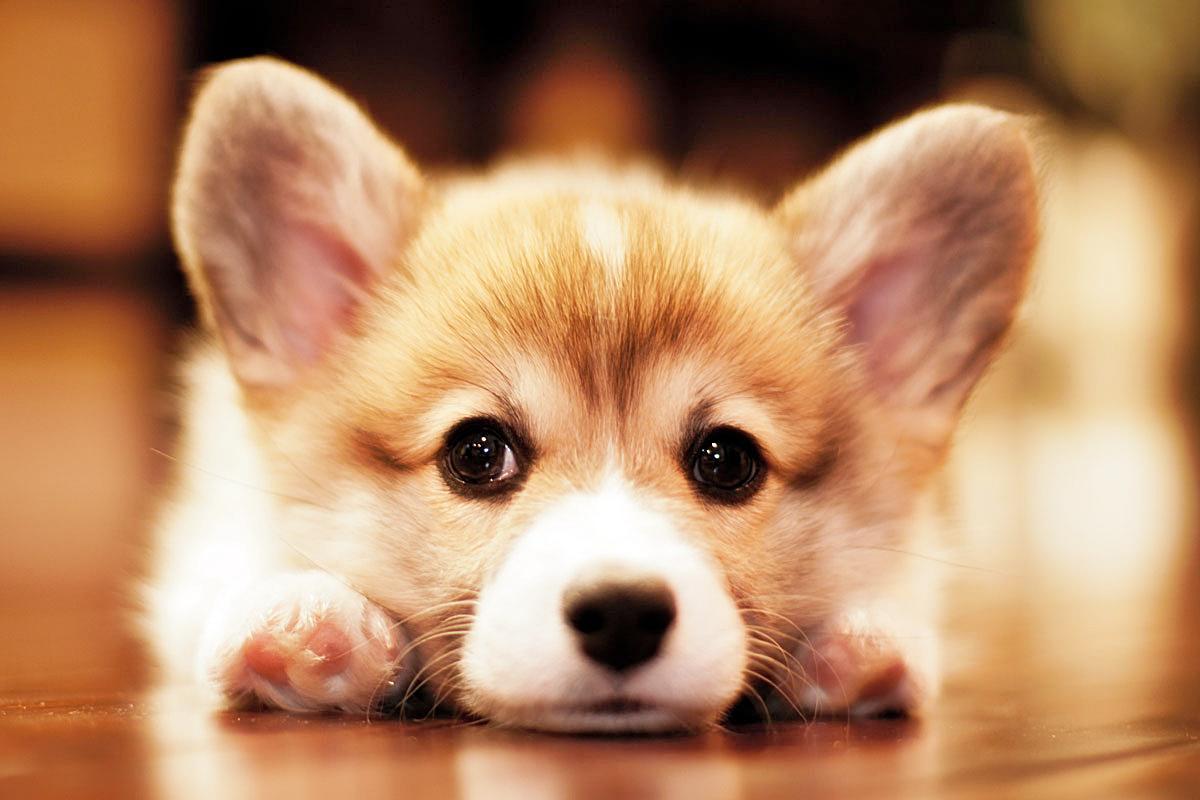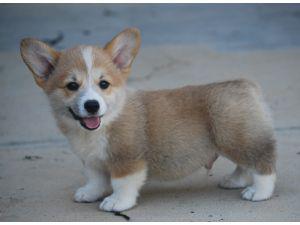The first image is the image on the left, the second image is the image on the right. For the images shown, is this caption "One puppy is sitting in each image." true? Answer yes or no. No. The first image is the image on the left, the second image is the image on the right. Assess this claim about the two images: "There is one sitting puppy in the image on the left.". Correct or not? Answer yes or no. No. 